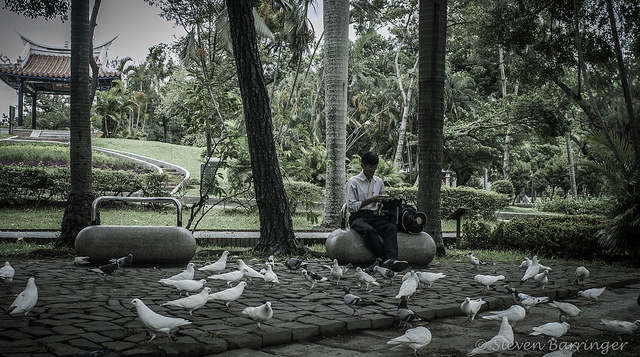Describe the objects in this image and their specific colors. I can see bird in gray, black, and darkgray tones, bench in gray, black, and darkgray tones, people in gray, black, and darkgray tones, bench in gray, black, and darkgray tones, and backpack in gray, black, purple, and darkgreen tones in this image. 